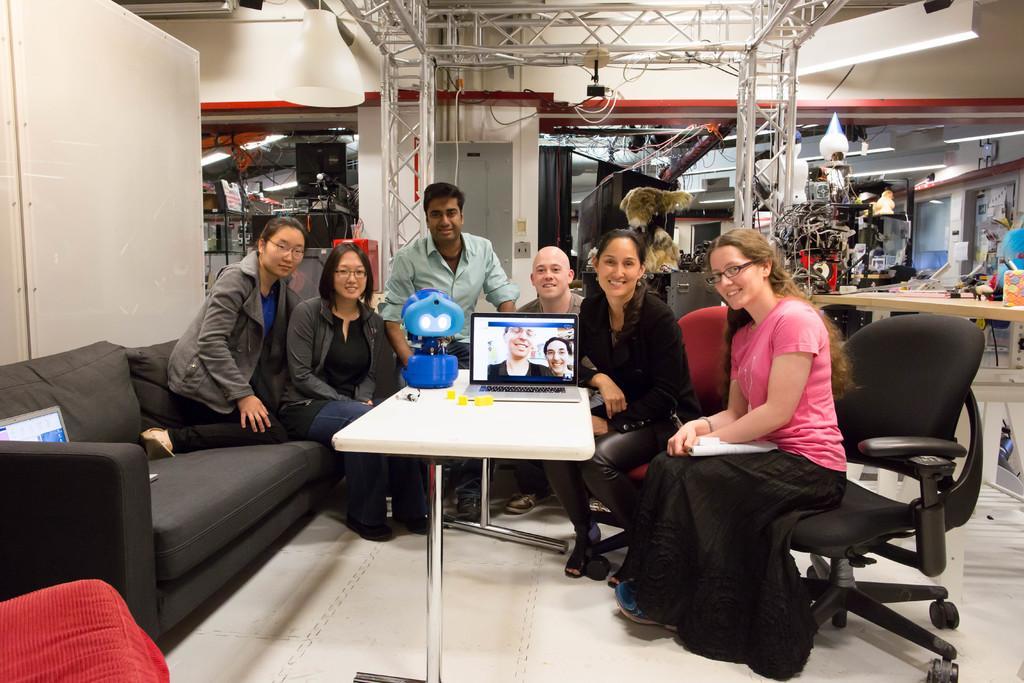How would you summarize this image in a sentence or two? In the picture there are group of people sitting , in between them there is a white color table and a laptop and a gadget placed , some of them are laughing behind them there are also few machinery items and a white color wall. 